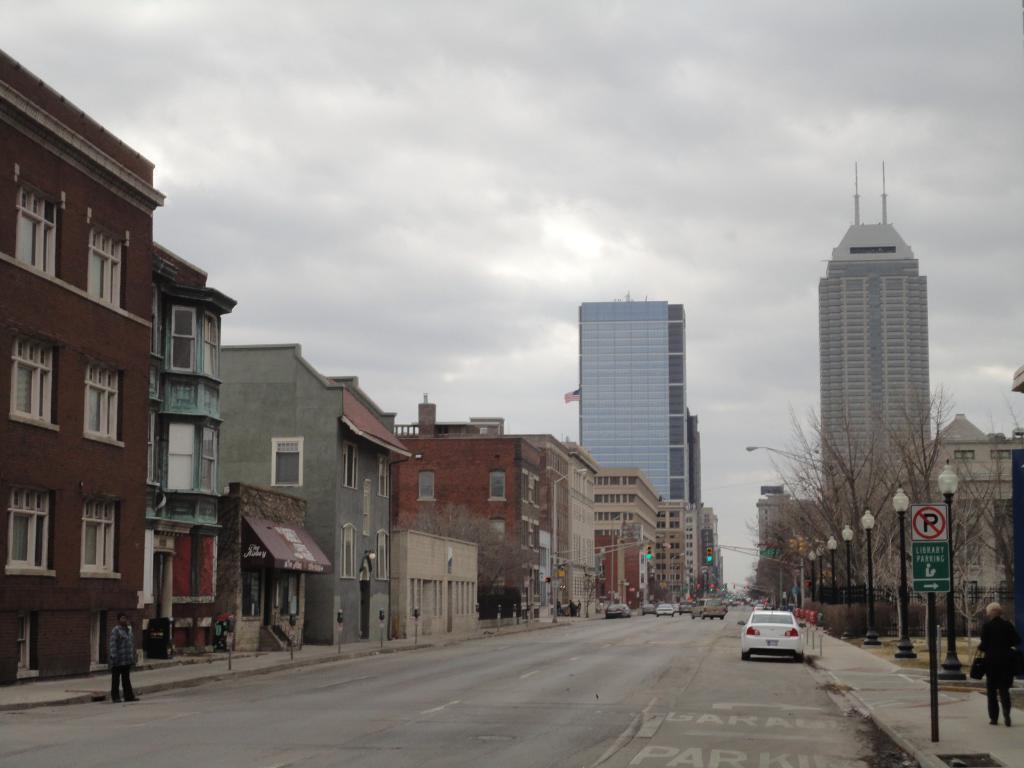Could you give a brief overview of what you see in this image? In this image there are trees, light poles, board, vehicle, people, road, buildings, cloudy sky and objects. Vehicles are on the road. 